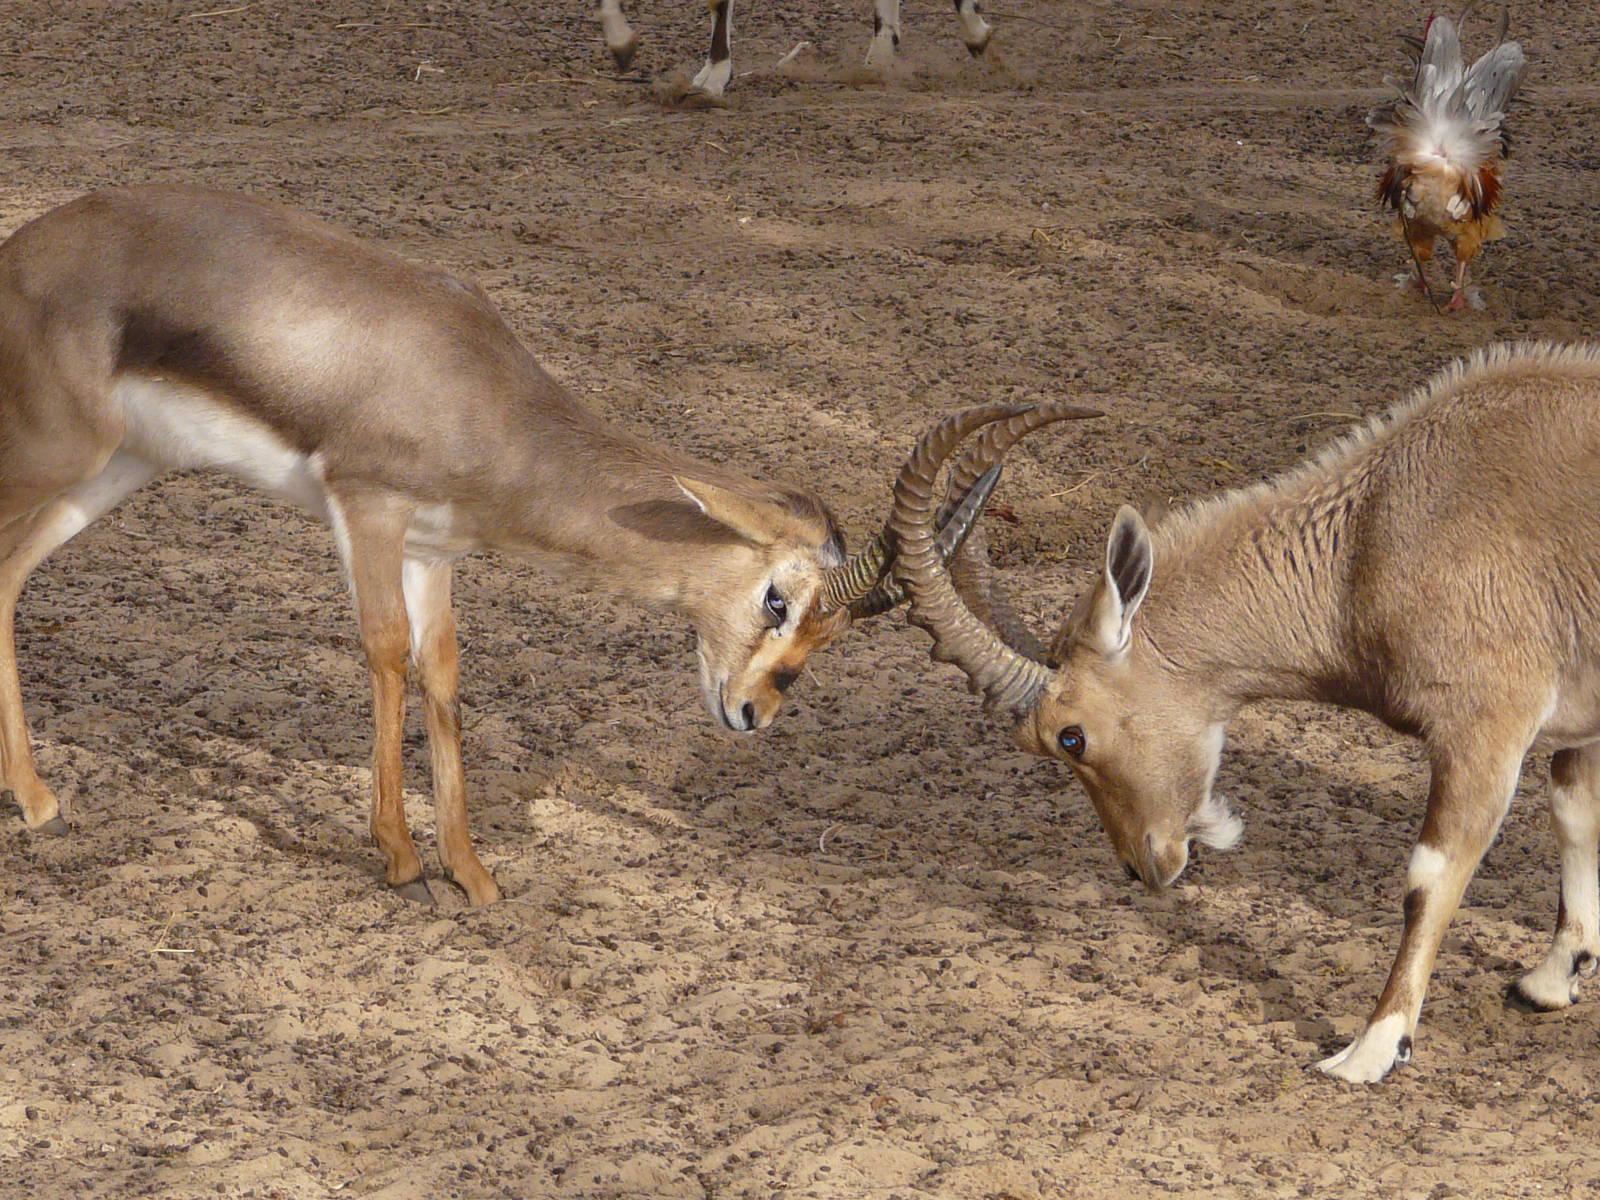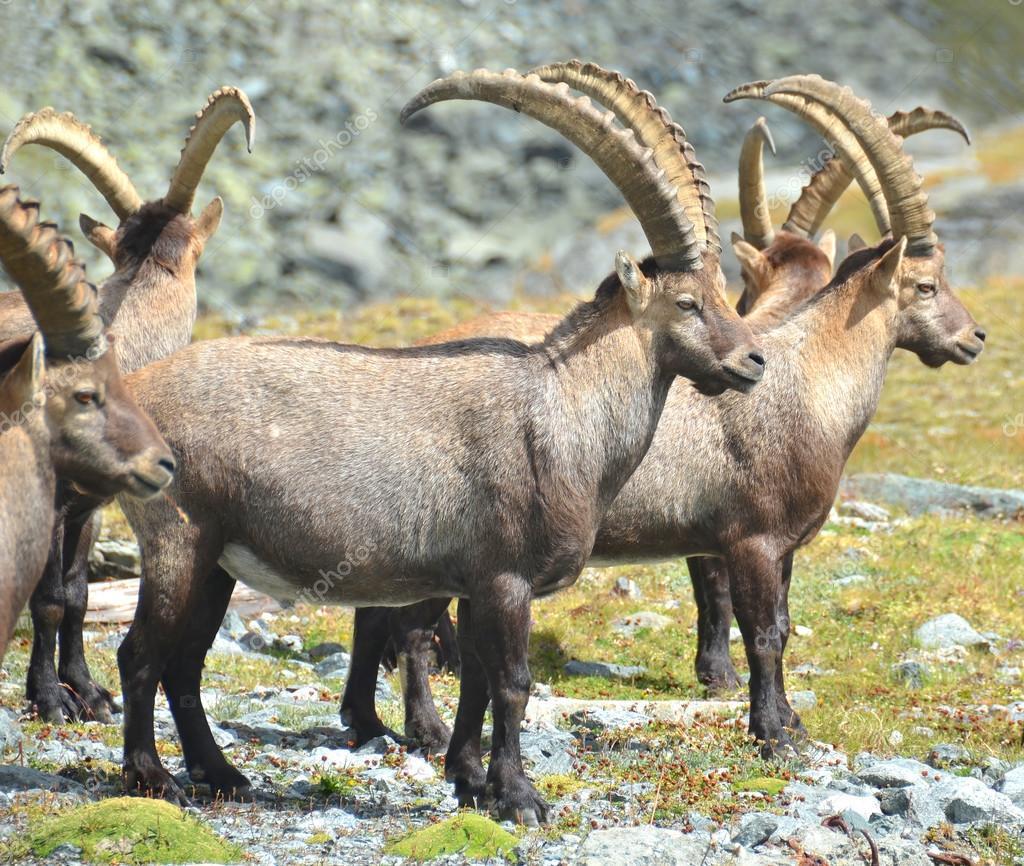The first image is the image on the left, the second image is the image on the right. Analyze the images presented: Is the assertion "A majority of horned animals in one image are rear-facing, and the other image shows a rocky ledge that drops off." valid? Answer yes or no. No. The first image is the image on the left, the second image is the image on the right. Given the left and right images, does the statement "There are more than four animals in the image on the left." hold true? Answer yes or no. No. 